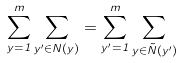Convert formula to latex. <formula><loc_0><loc_0><loc_500><loc_500>\sum _ { y = 1 } ^ { m } \sum _ { y ^ { \prime } \in N \left ( y \right ) } = \sum _ { y ^ { \prime } = 1 } ^ { m } \sum _ { y \in \tilde { N } \left ( y ^ { \prime } \right ) }</formula> 